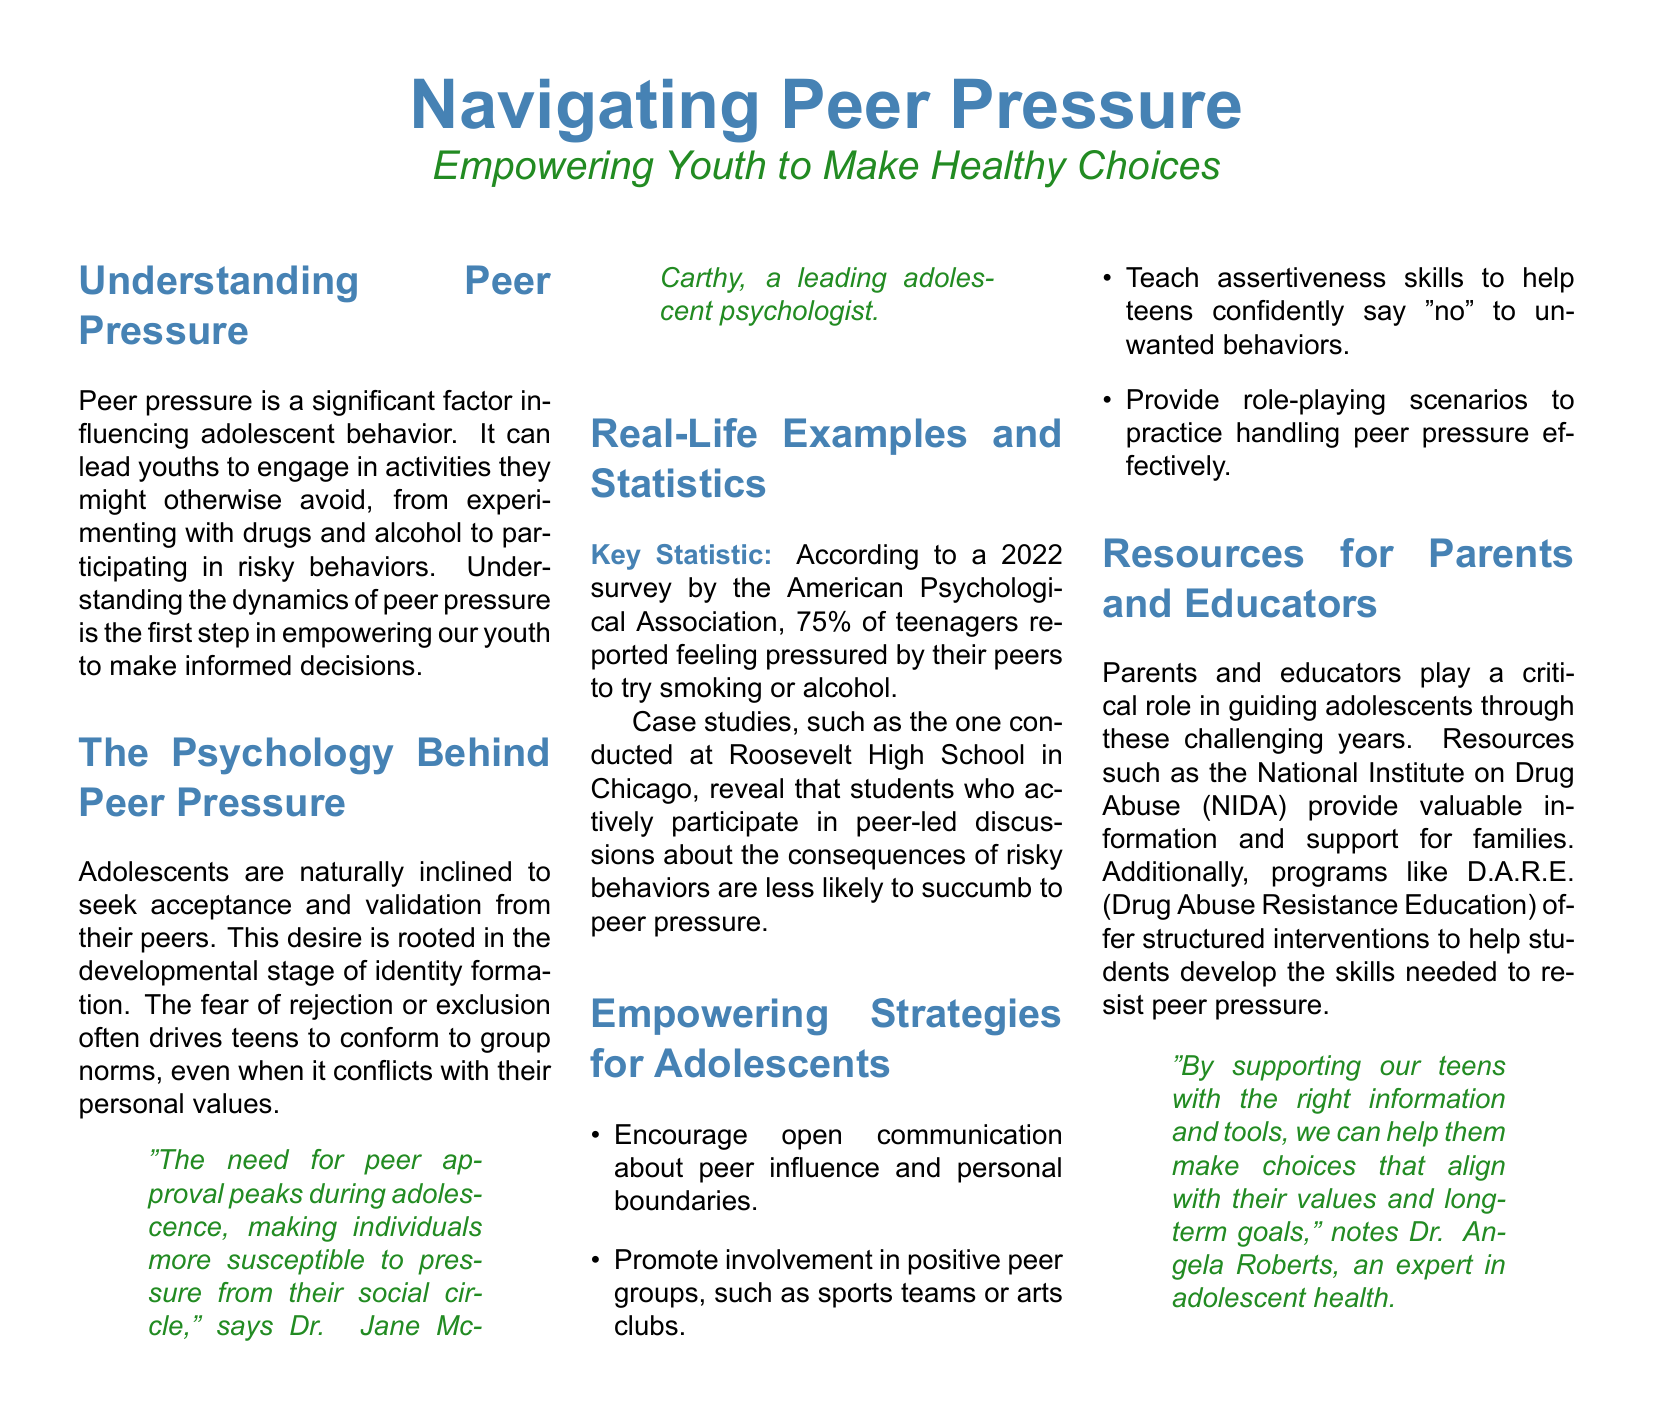What is the title of the article? The title is prominently featured at the top of the document, indicating the main subject of the article.
Answer: Navigating Peer Pressure What percentage of teenagers reported feeling pressured to try smoking or alcohol? This statistic is presented clearly within the real-life examples and statistics section, highlighting the prevalence of peer pressure.
Answer: 75% Who conducted the survey referenced in the document? The document specifies the organization responsible for the survey, offering credibility to the statistic provided.
Answer: American Psychological Association What is one of the empowering strategies for adolescents mentioned? The strategies listed in the document are intended to empower youth and provide them with tools to resist peer pressure.
Answer: Teach assertiveness skills What program is mentioned as a resource for students to resist peer pressure? This program is highlighted in the resources for parents and educators section, providing structured intervention for adolescents.
Answer: D.A.R.E Who is the leading adolescent psychologist quoted in the document? The document includes a quote from a notable expert, emphasizing the psychological perspective on peer pressure.
Answer: Dr. Jane McCarthy What is the main theme of the article? The main theme is outlined in both the title and the introduction, focusing on youth empowerment in the face of peer pressure.
Answer: Empowering Youth to Make Healthy Choices What color is used for the main title? The color used for the main title is an essential design element that impacts the visual appeal of the article.
Answer: My blue 